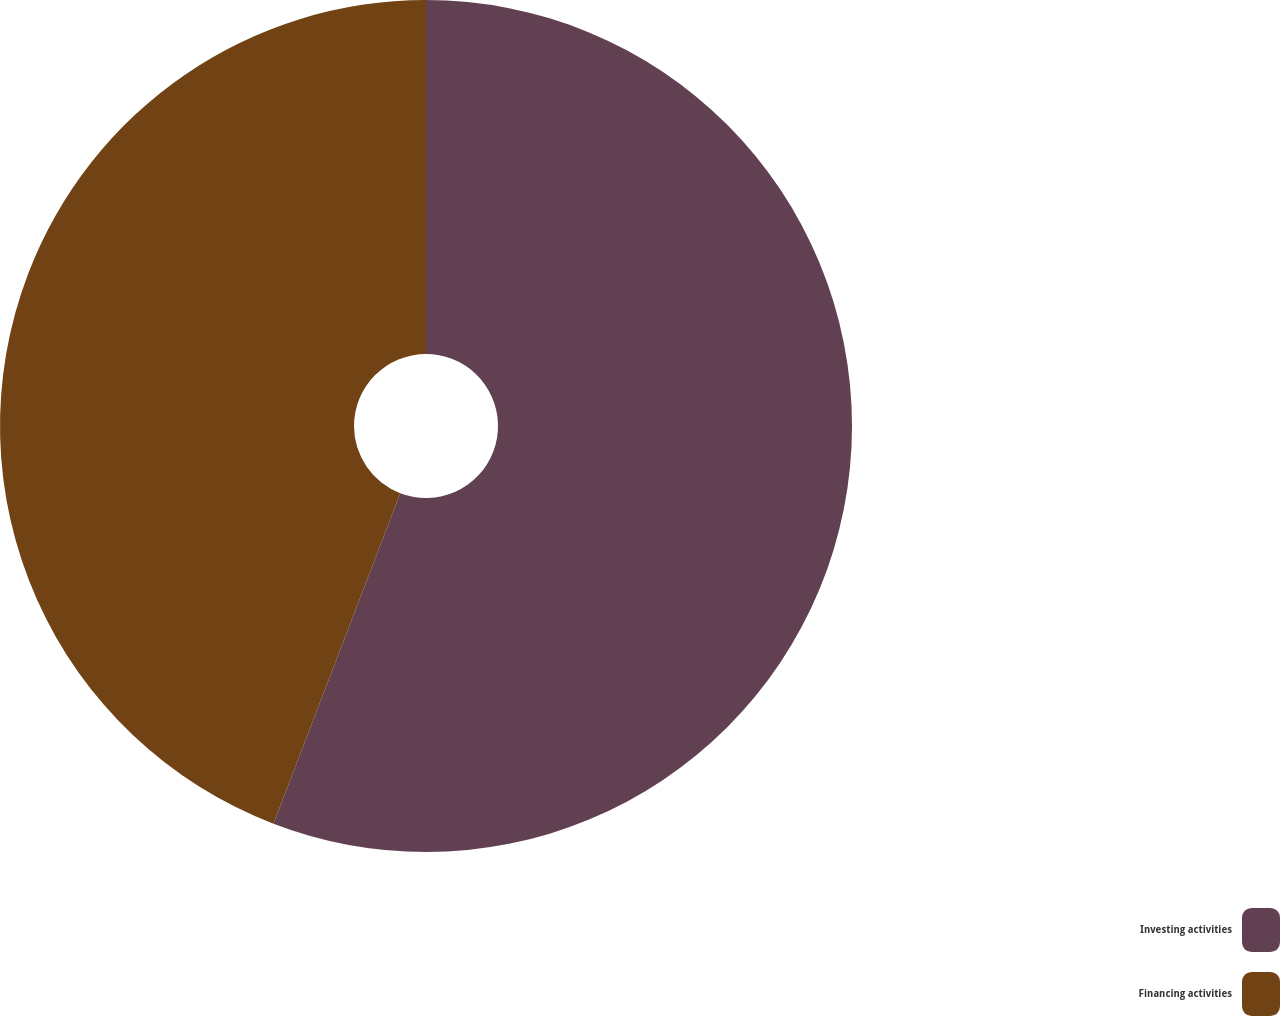Convert chart. <chart><loc_0><loc_0><loc_500><loc_500><pie_chart><fcel>Investing activities<fcel>Financing activities<nl><fcel>55.83%<fcel>44.17%<nl></chart> 